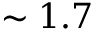Convert formula to latex. <formula><loc_0><loc_0><loc_500><loc_500>\sim 1 . 7</formula> 